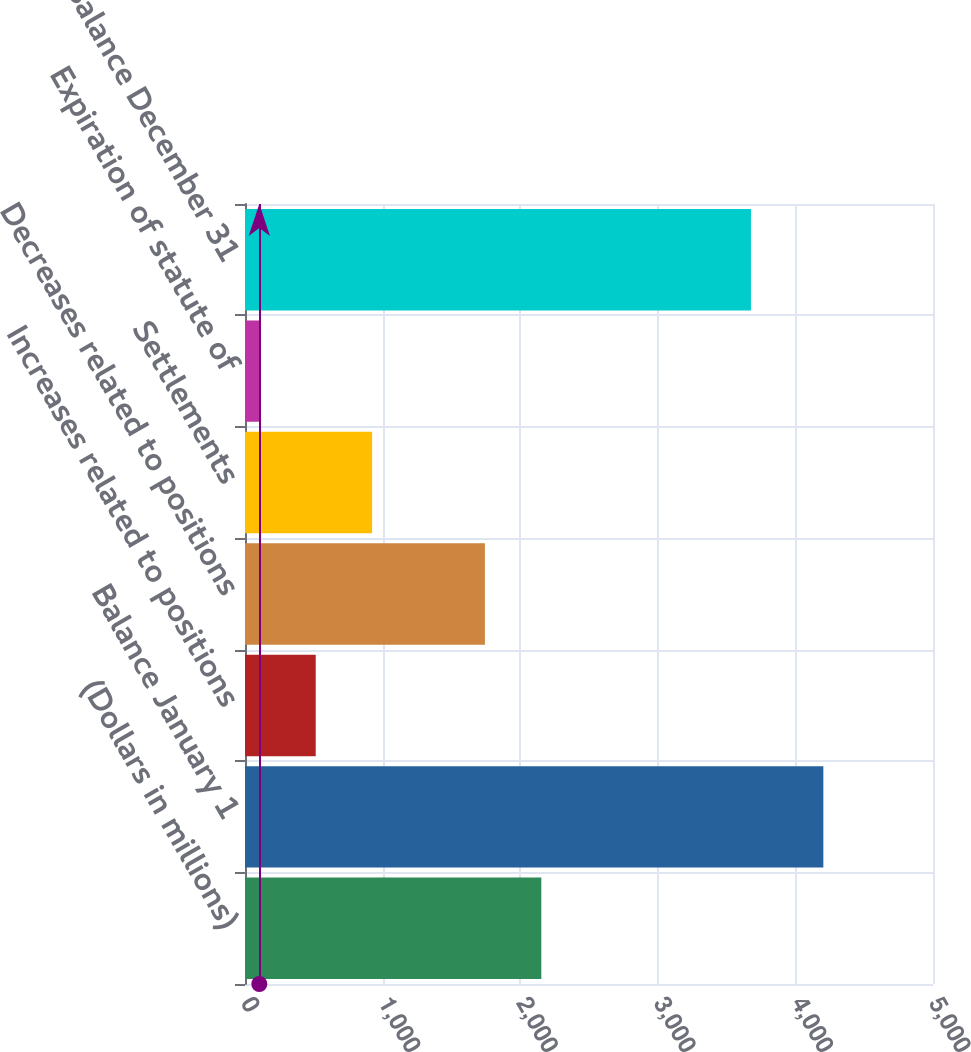Convert chart to OTSL. <chart><loc_0><loc_0><loc_500><loc_500><bar_chart><fcel>(Dollars in millions)<fcel>Balance January 1<fcel>Increases related to positions<fcel>Decreases related to positions<fcel>Settlements<fcel>Expiration of statute of<fcel>Balance December 31<nl><fcel>2153.5<fcel>4203<fcel>513.9<fcel>1743.6<fcel>923.8<fcel>104<fcel>3677<nl></chart> 